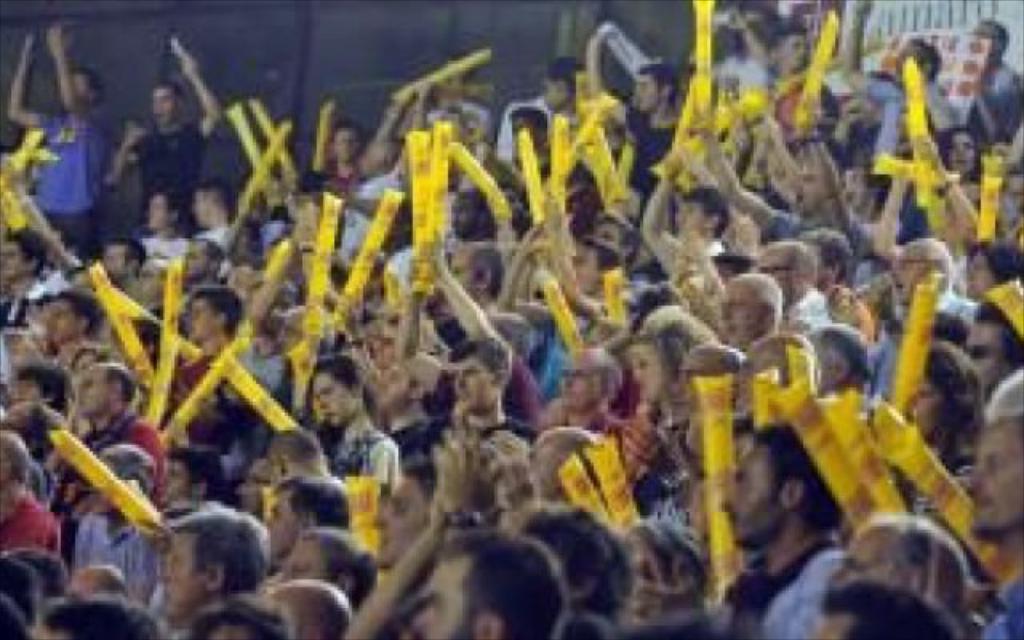Please provide a concise description of this image. In the image few people are standing and holding some yellow color balloons. Behind them there is fencing. 